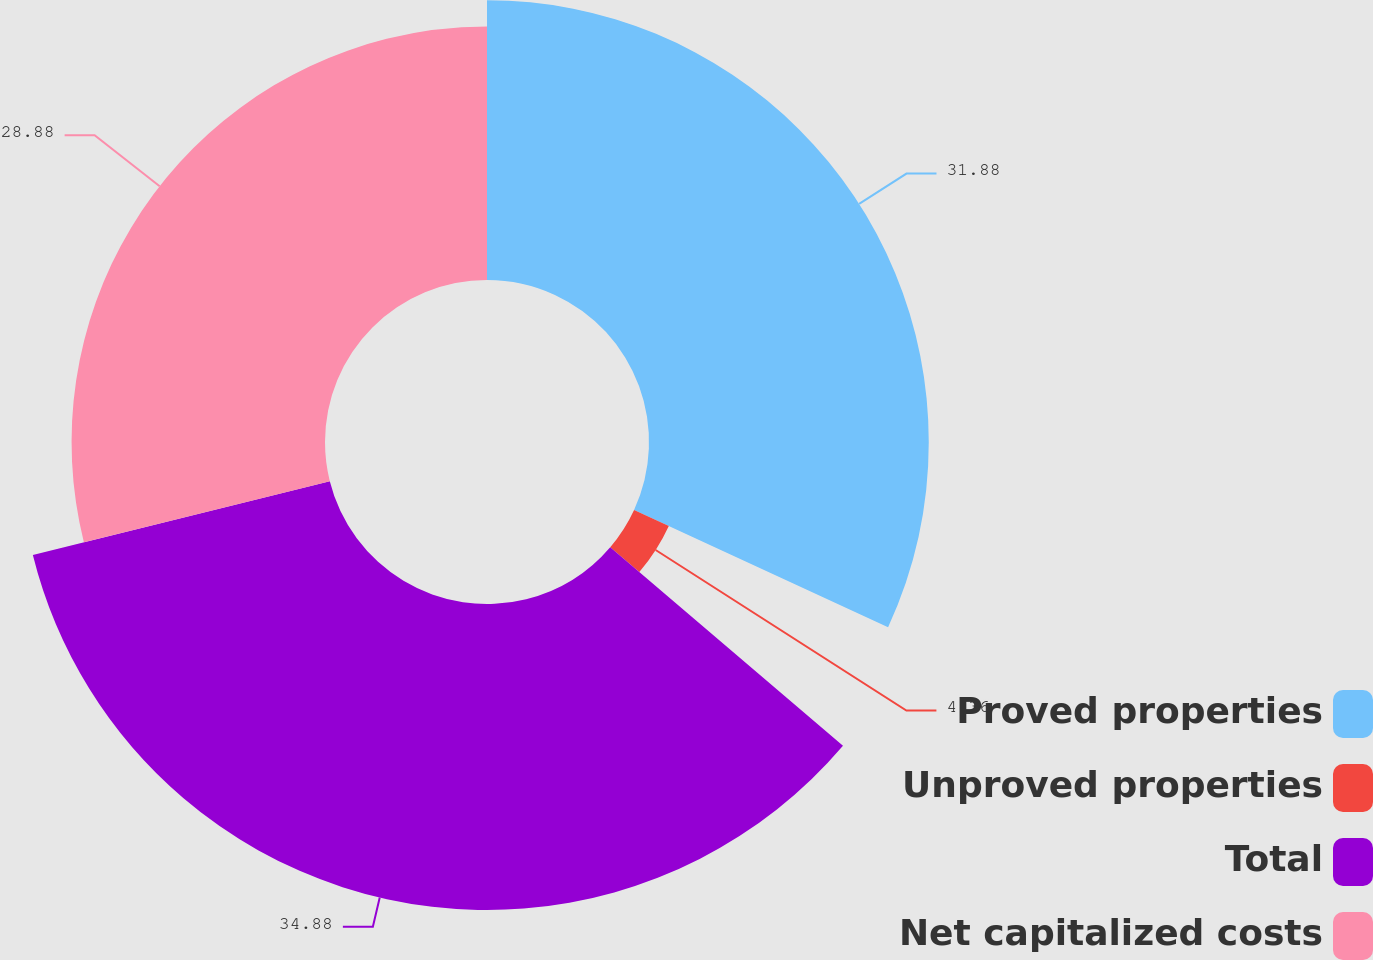Convert chart. <chart><loc_0><loc_0><loc_500><loc_500><pie_chart><fcel>Proved properties<fcel>Unproved properties<fcel>Total<fcel>Net capitalized costs<nl><fcel>31.88%<fcel>4.36%<fcel>34.87%<fcel>28.88%<nl></chart> 